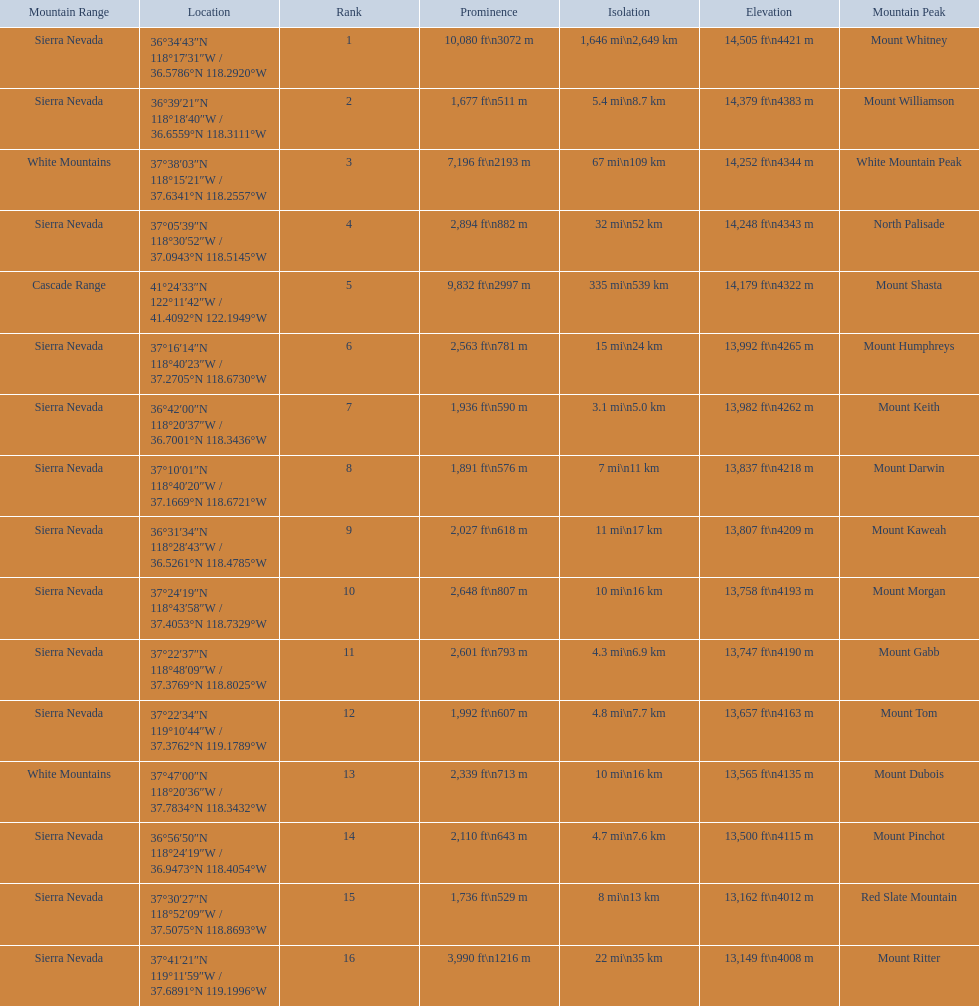How much taller is the mountain peak of mount williamson than that of mount keith? 397 ft. 